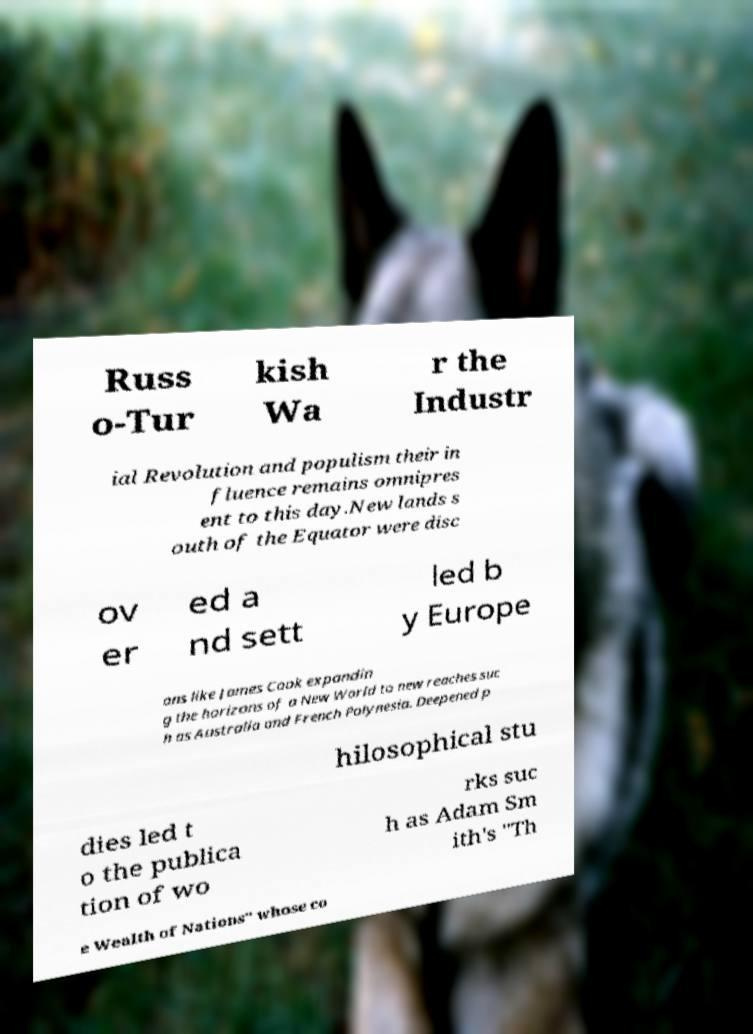Can you read and provide the text displayed in the image?This photo seems to have some interesting text. Can you extract and type it out for me? Russ o-Tur kish Wa r the Industr ial Revolution and populism their in fluence remains omnipres ent to this day.New lands s outh of the Equator were disc ov er ed a nd sett led b y Europe ans like James Cook expandin g the horizons of a New World to new reaches suc h as Australia and French Polynesia. Deepened p hilosophical stu dies led t o the publica tion of wo rks suc h as Adam Sm ith's "Th e Wealth of Nations" whose co 